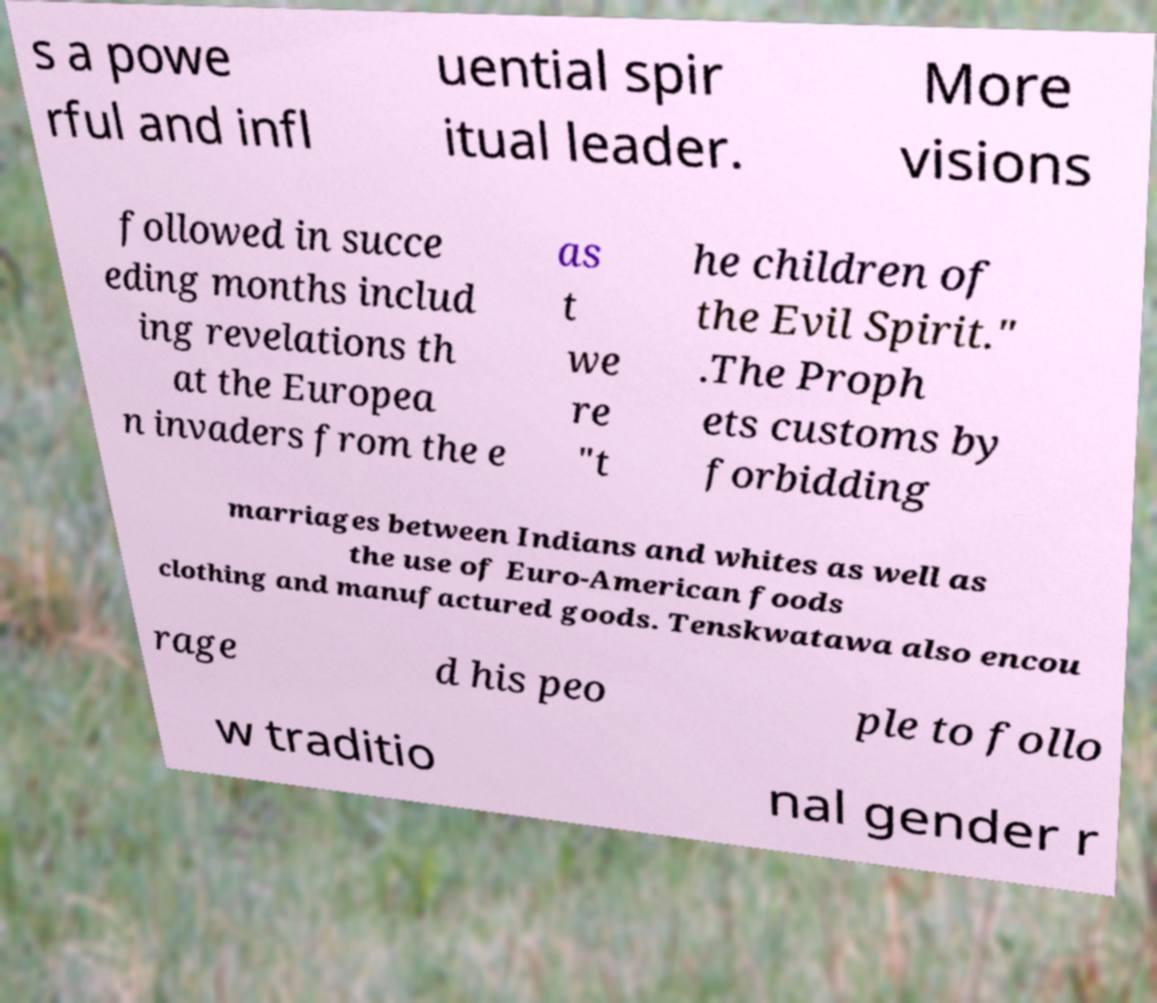I need the written content from this picture converted into text. Can you do that? s a powe rful and infl uential spir itual leader. More visions followed in succe eding months includ ing revelations th at the Europea n invaders from the e as t we re "t he children of the Evil Spirit." .The Proph ets customs by forbidding marriages between Indians and whites as well as the use of Euro-American foods clothing and manufactured goods. Tenskwatawa also encou rage d his peo ple to follo w traditio nal gender r 